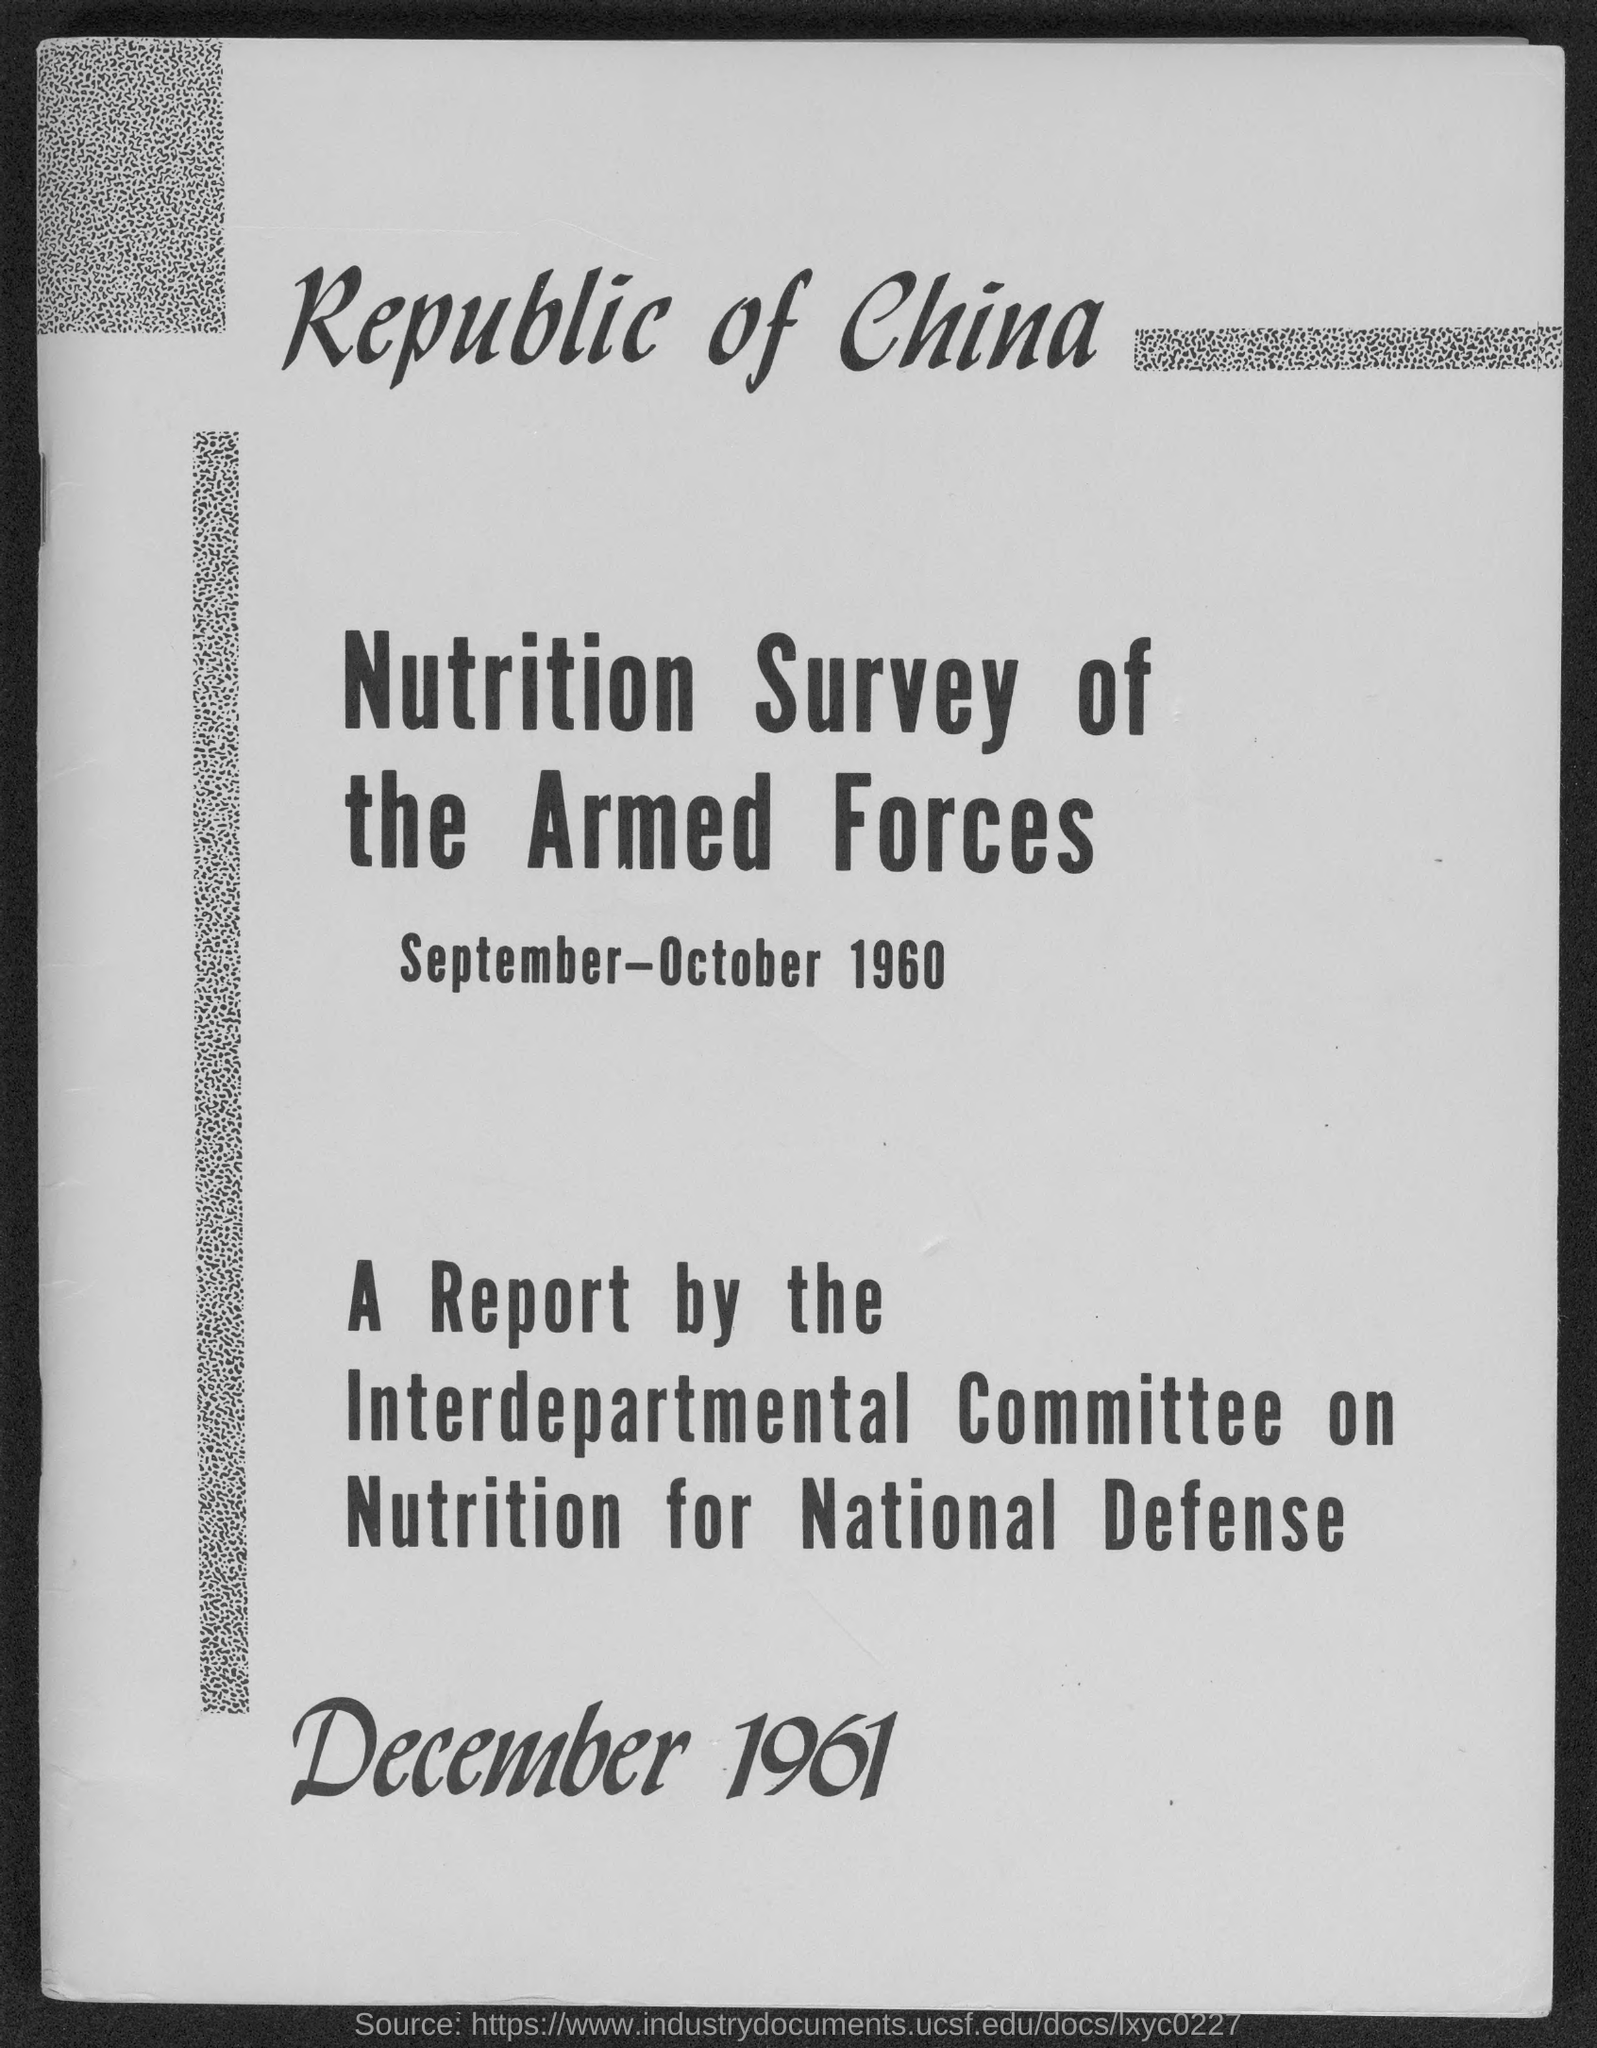Who wrote the report?
Ensure brevity in your answer.  Interdepartmental Committee on Nutrition for National Defense. 